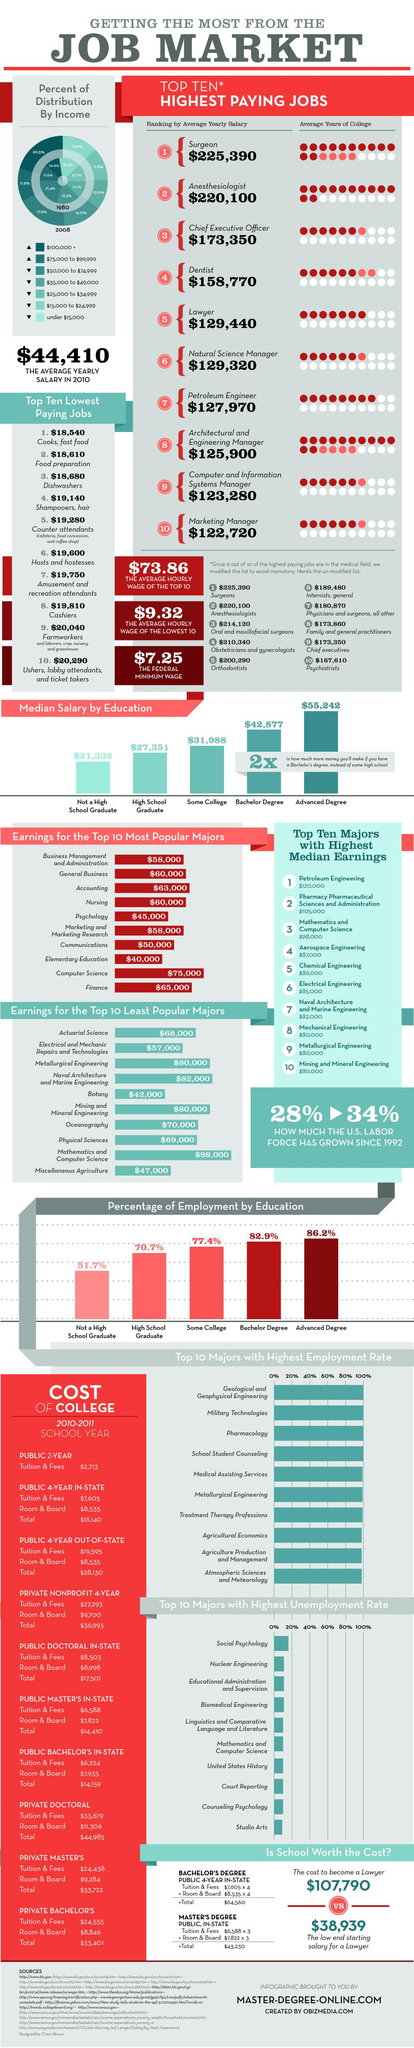Highlight a few significant elements in this photo. The Chief Executive Officer's ranking is based on their average yearly salary, which is given a value of 3. Advanced degrees in the United States are associated with the highest rate of employment. According to a recent survey, the second highest paid job in the United States is that of an anesthesiologist. The average amount of time spent in college by a lawyer in the United States is approximately 7 years. The ranking of a surgeon based on their average yearly salary is determined by their salary. 